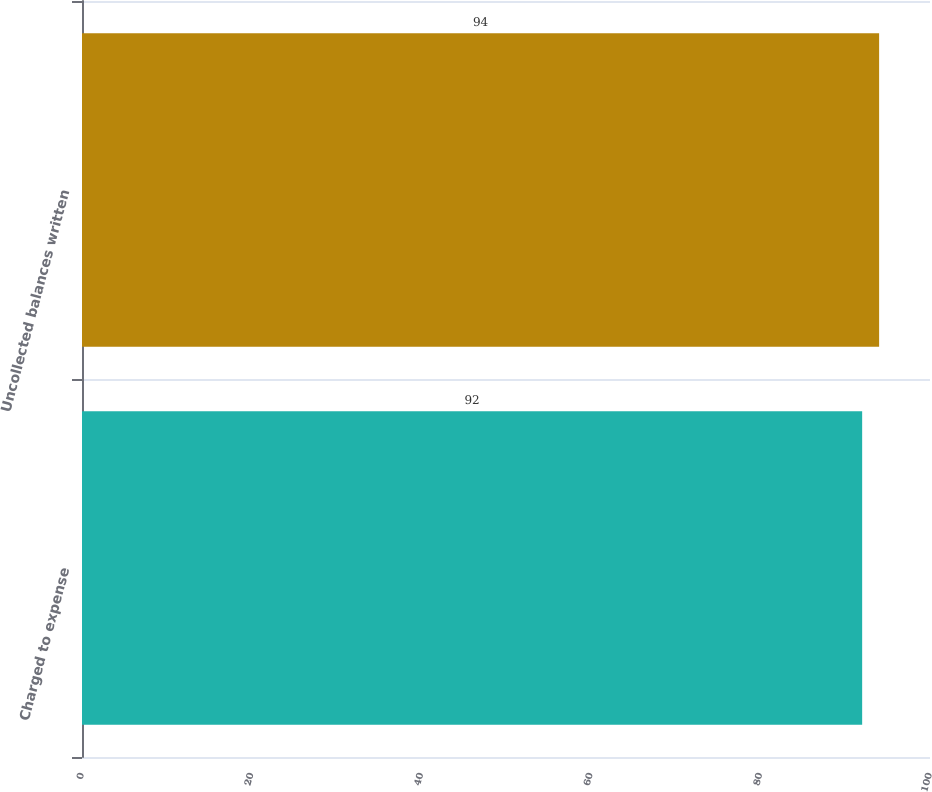Convert chart to OTSL. <chart><loc_0><loc_0><loc_500><loc_500><bar_chart><fcel>Charged to expense<fcel>Uncollected balances written<nl><fcel>92<fcel>94<nl></chart> 